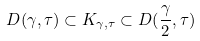Convert formula to latex. <formula><loc_0><loc_0><loc_500><loc_500>D ( \gamma , \tau ) \subset K _ { \gamma , \tau } \subset D ( \frac { \gamma } { 2 } , \tau )</formula> 